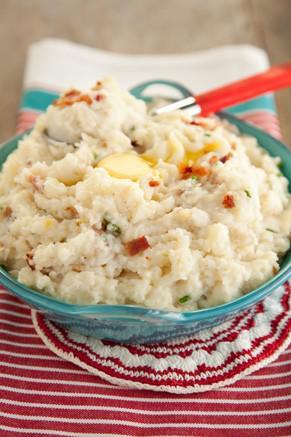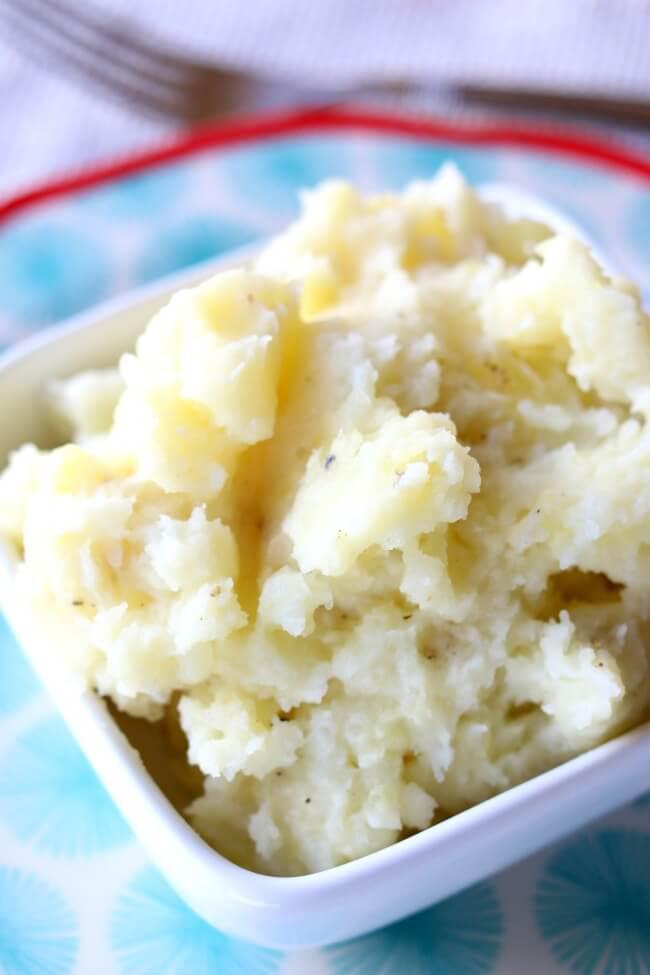The first image is the image on the left, the second image is the image on the right. Analyze the images presented: Is the assertion "Some of the mashed potatoes are in a green bowl sitting on top of a striped tablecloth." valid? Answer yes or no. Yes. The first image is the image on the left, the second image is the image on the right. Examine the images to the left and right. Is the description "The mashed potatoes in the right image are inside of a white container." accurate? Answer yes or no. Yes. 